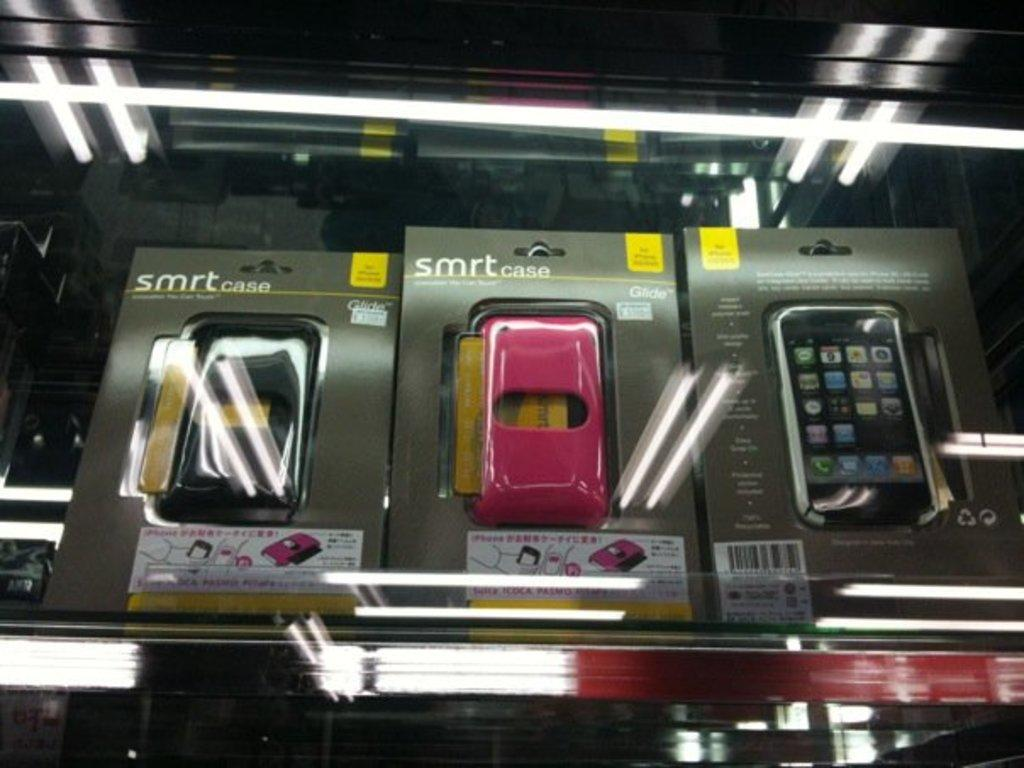<image>
Give a short and clear explanation of the subsequent image. smrt cases in their wrapped plastic packaging on display 